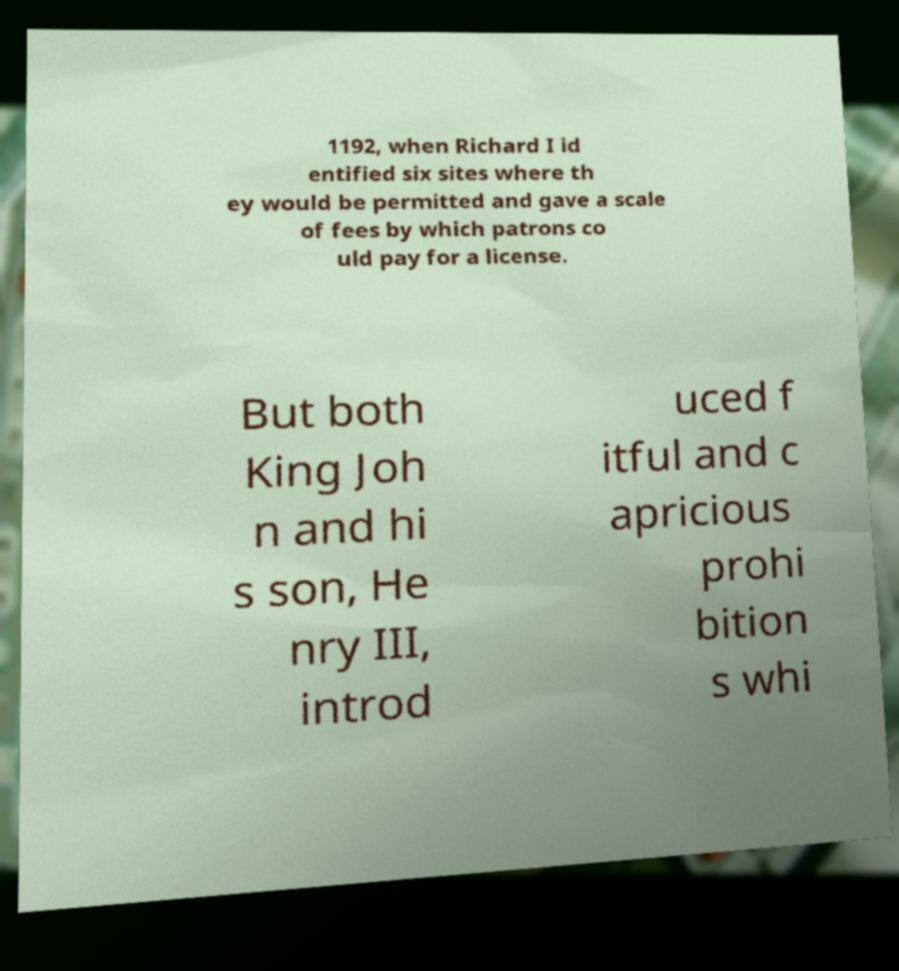What messages or text are displayed in this image? I need them in a readable, typed format. 1192, when Richard I id entified six sites where th ey would be permitted and gave a scale of fees by which patrons co uld pay for a license. But both King Joh n and hi s son, He nry III, introd uced f itful and c apricious prohi bition s whi 